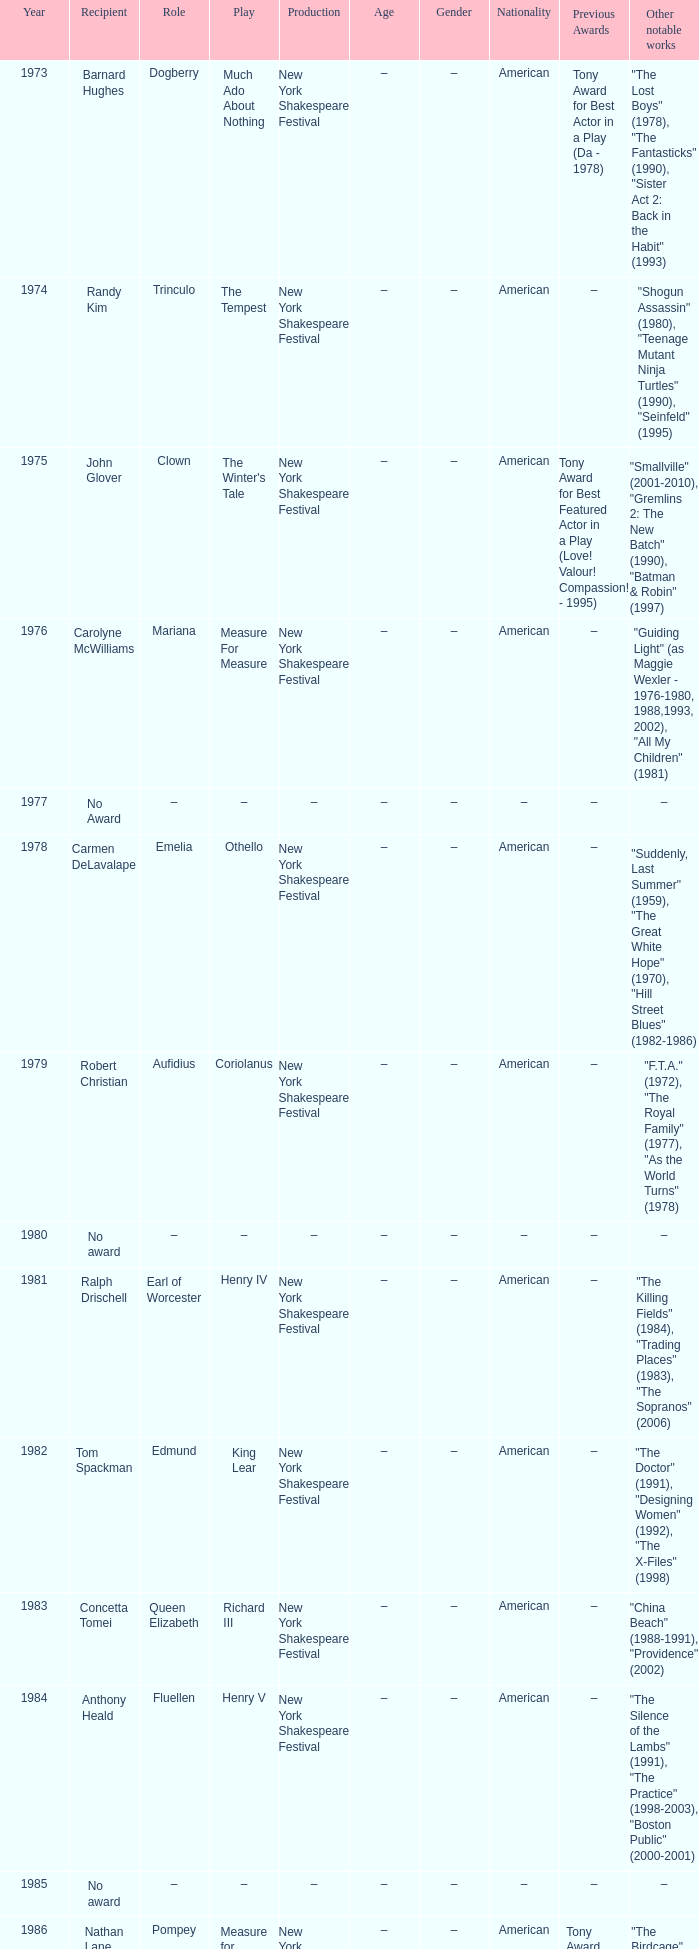Name the recipient of much ado about nothing for 1973 Barnard Hughes. 